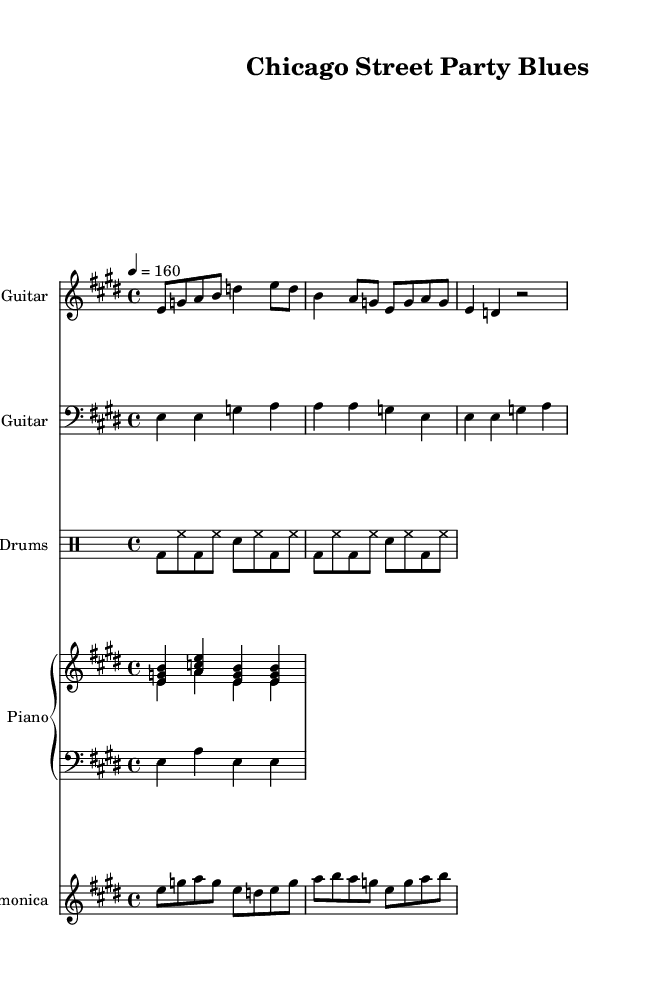What is the key signature of this music? The key signature is E major, which has four sharps (F#, C#, G#, D#). This can be found in the global settings of the sheet music, which states the key is set to E major.
Answer: E major What is the time signature of this music? The time signature is 4/4, indicated in the global settings of the score. This means there are four beats in a measure and the quarter note gets one beat.
Answer: 4/4 What is the tempo marking of this music? The tempo marking is 160 beats per minute, which can be observed in the global section where it says "tempo 4 = 160." This indicates a quickly paced performance.
Answer: 160 How many instruments are featured in this music? There are five instruments featured: Electric Guitar, Bass Guitar, Drums, Piano, and Harmonica. This is clear from the separate staves assigned to each instrument in the score.
Answer: Five What type of blues style is represented in this sheet music? The sheet music represents Chicago blues, characterized by its upbeat tempo and emphasis on electric instruments, such as guitar and harmonica, which are typical for dance parties. This can be inferred from the title and the rhythmic drive in the music.
Answer: Chicago blues What is the rhythmic pattern of the drums in the first measure? The first measure of the drums shows a kick drum on beats 1 and 3, and hi-hat continuous on eighth notes; this establishes a solid backbeat typical of upbeat dance rhythms.
Answer: Kick and hi-hat pattern What do the chord symbols indicate for the piano part? The chord symbols indicate E major, A major, and B major chords in the right hand, reflecting the harmonic structure typical of blues music, providing a foundation for the melodies and solos.
Answer: E, A, B chords 